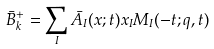<formula> <loc_0><loc_0><loc_500><loc_500>\bar { B } _ { k } ^ { + } = \sum _ { I } \bar { A } _ { I } ( x ; t ) x _ { I } M _ { I } ( - t ; q , t )</formula> 